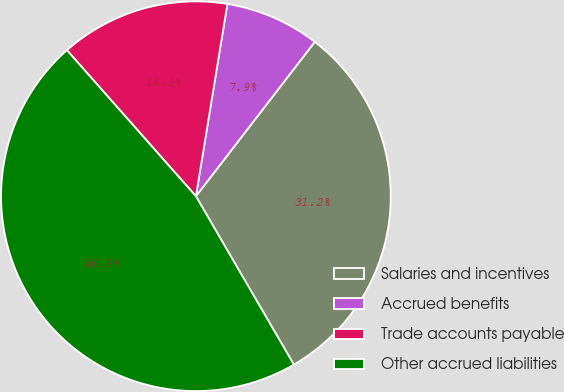Convert chart. <chart><loc_0><loc_0><loc_500><loc_500><pie_chart><fcel>Salaries and incentives<fcel>Accrued benefits<fcel>Trade accounts payable<fcel>Other accrued liabilities<nl><fcel>31.17%<fcel>7.86%<fcel>14.1%<fcel>46.87%<nl></chart> 